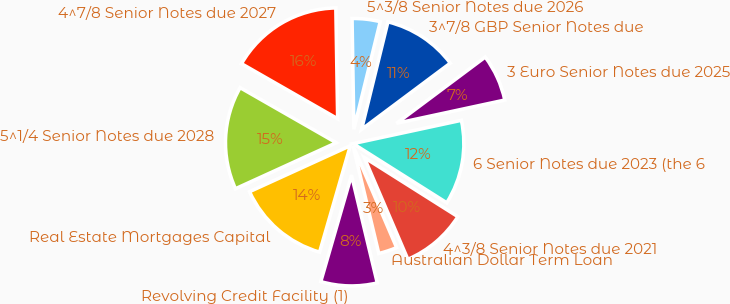Convert chart. <chart><loc_0><loc_0><loc_500><loc_500><pie_chart><fcel>Revolving Credit Facility (1)<fcel>Australian Dollar Term Loan<fcel>4^3/8 Senior Notes due 2021<fcel>6 Senior Notes due 2023 (the 6<fcel>3 Euro Senior Notes due 2025<fcel>3^7/8 GBP Senior Notes due<fcel>5^3/8 Senior Notes due 2026<fcel>4^7/8 Senior Notes due 2027<fcel>5^1/4 Senior Notes due 2028<fcel>Real Estate Mortgages Capital<nl><fcel>8.21%<fcel>2.71%<fcel>9.59%<fcel>12.34%<fcel>6.84%<fcel>10.96%<fcel>4.09%<fcel>16.46%<fcel>15.09%<fcel>13.71%<nl></chart> 